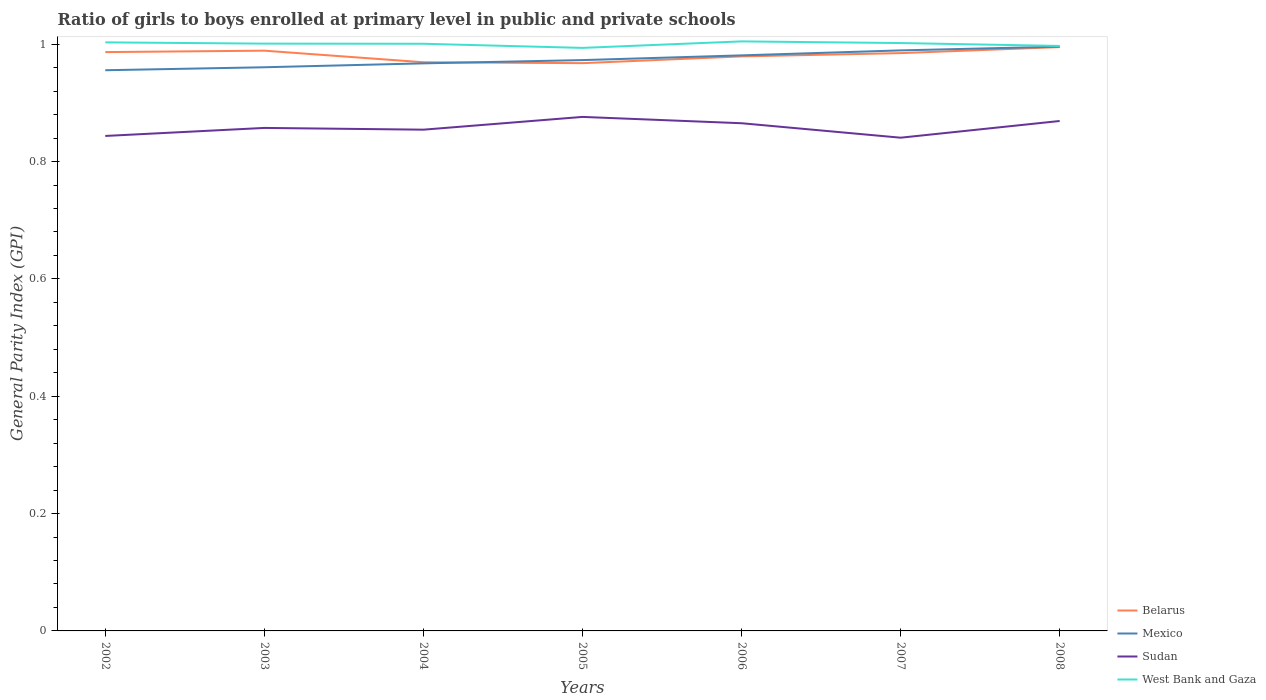Across all years, what is the maximum general parity index in West Bank and Gaza?
Offer a very short reply. 0.99. What is the total general parity index in Sudan in the graph?
Your answer should be very brief. -0.02. What is the difference between the highest and the second highest general parity index in West Bank and Gaza?
Provide a succinct answer. 0.01. What is the difference between the highest and the lowest general parity index in Mexico?
Ensure brevity in your answer.  3. How many lines are there?
Your answer should be very brief. 4. How many years are there in the graph?
Give a very brief answer. 7. Does the graph contain any zero values?
Ensure brevity in your answer.  No. Where does the legend appear in the graph?
Give a very brief answer. Bottom right. What is the title of the graph?
Offer a terse response. Ratio of girls to boys enrolled at primary level in public and private schools. Does "Comoros" appear as one of the legend labels in the graph?
Offer a very short reply. No. What is the label or title of the Y-axis?
Make the answer very short. General Parity Index (GPI). What is the General Parity Index (GPI) in Belarus in 2002?
Ensure brevity in your answer.  0.99. What is the General Parity Index (GPI) in Mexico in 2002?
Give a very brief answer. 0.96. What is the General Parity Index (GPI) of Sudan in 2002?
Keep it short and to the point. 0.84. What is the General Parity Index (GPI) in West Bank and Gaza in 2002?
Your answer should be compact. 1. What is the General Parity Index (GPI) in Belarus in 2003?
Your answer should be compact. 0.99. What is the General Parity Index (GPI) of Mexico in 2003?
Offer a terse response. 0.96. What is the General Parity Index (GPI) of Sudan in 2003?
Offer a terse response. 0.86. What is the General Parity Index (GPI) of West Bank and Gaza in 2003?
Offer a very short reply. 1. What is the General Parity Index (GPI) of Belarus in 2004?
Provide a short and direct response. 0.97. What is the General Parity Index (GPI) of Mexico in 2004?
Your answer should be very brief. 0.97. What is the General Parity Index (GPI) in Sudan in 2004?
Give a very brief answer. 0.85. What is the General Parity Index (GPI) of West Bank and Gaza in 2004?
Offer a terse response. 1. What is the General Parity Index (GPI) in Belarus in 2005?
Provide a short and direct response. 0.97. What is the General Parity Index (GPI) of Mexico in 2005?
Offer a very short reply. 0.97. What is the General Parity Index (GPI) of Sudan in 2005?
Keep it short and to the point. 0.88. What is the General Parity Index (GPI) of West Bank and Gaza in 2005?
Keep it short and to the point. 0.99. What is the General Parity Index (GPI) in Belarus in 2006?
Keep it short and to the point. 0.98. What is the General Parity Index (GPI) of Mexico in 2006?
Your response must be concise. 0.98. What is the General Parity Index (GPI) of Sudan in 2006?
Offer a terse response. 0.87. What is the General Parity Index (GPI) of West Bank and Gaza in 2006?
Ensure brevity in your answer.  1. What is the General Parity Index (GPI) in Belarus in 2007?
Give a very brief answer. 0.98. What is the General Parity Index (GPI) in Mexico in 2007?
Your response must be concise. 0.99. What is the General Parity Index (GPI) in Sudan in 2007?
Provide a short and direct response. 0.84. What is the General Parity Index (GPI) of West Bank and Gaza in 2007?
Your answer should be very brief. 1. What is the General Parity Index (GPI) in Belarus in 2008?
Provide a short and direct response. 1. What is the General Parity Index (GPI) of Mexico in 2008?
Provide a succinct answer. 1. What is the General Parity Index (GPI) in Sudan in 2008?
Ensure brevity in your answer.  0.87. What is the General Parity Index (GPI) in West Bank and Gaza in 2008?
Keep it short and to the point. 1. Across all years, what is the maximum General Parity Index (GPI) in Belarus?
Ensure brevity in your answer.  1. Across all years, what is the maximum General Parity Index (GPI) in Mexico?
Your response must be concise. 1. Across all years, what is the maximum General Parity Index (GPI) of Sudan?
Your answer should be very brief. 0.88. Across all years, what is the maximum General Parity Index (GPI) of West Bank and Gaza?
Offer a very short reply. 1. Across all years, what is the minimum General Parity Index (GPI) of Belarus?
Make the answer very short. 0.97. Across all years, what is the minimum General Parity Index (GPI) in Mexico?
Your answer should be very brief. 0.96. Across all years, what is the minimum General Parity Index (GPI) in Sudan?
Give a very brief answer. 0.84. Across all years, what is the minimum General Parity Index (GPI) in West Bank and Gaza?
Provide a short and direct response. 0.99. What is the total General Parity Index (GPI) of Belarus in the graph?
Provide a succinct answer. 6.87. What is the total General Parity Index (GPI) in Mexico in the graph?
Offer a terse response. 6.82. What is the total General Parity Index (GPI) of Sudan in the graph?
Ensure brevity in your answer.  6.01. What is the total General Parity Index (GPI) of West Bank and Gaza in the graph?
Offer a very short reply. 7. What is the difference between the General Parity Index (GPI) in Belarus in 2002 and that in 2003?
Make the answer very short. -0. What is the difference between the General Parity Index (GPI) of Mexico in 2002 and that in 2003?
Provide a succinct answer. -0.01. What is the difference between the General Parity Index (GPI) of Sudan in 2002 and that in 2003?
Provide a succinct answer. -0.01. What is the difference between the General Parity Index (GPI) of West Bank and Gaza in 2002 and that in 2003?
Offer a terse response. 0. What is the difference between the General Parity Index (GPI) in Belarus in 2002 and that in 2004?
Provide a succinct answer. 0.02. What is the difference between the General Parity Index (GPI) in Mexico in 2002 and that in 2004?
Give a very brief answer. -0.01. What is the difference between the General Parity Index (GPI) of Sudan in 2002 and that in 2004?
Provide a short and direct response. -0.01. What is the difference between the General Parity Index (GPI) in West Bank and Gaza in 2002 and that in 2004?
Your answer should be very brief. 0. What is the difference between the General Parity Index (GPI) in Belarus in 2002 and that in 2005?
Make the answer very short. 0.02. What is the difference between the General Parity Index (GPI) in Mexico in 2002 and that in 2005?
Give a very brief answer. -0.02. What is the difference between the General Parity Index (GPI) of Sudan in 2002 and that in 2005?
Ensure brevity in your answer.  -0.03. What is the difference between the General Parity Index (GPI) of West Bank and Gaza in 2002 and that in 2005?
Keep it short and to the point. 0.01. What is the difference between the General Parity Index (GPI) in Belarus in 2002 and that in 2006?
Your response must be concise. 0.01. What is the difference between the General Parity Index (GPI) of Mexico in 2002 and that in 2006?
Offer a terse response. -0.03. What is the difference between the General Parity Index (GPI) in Sudan in 2002 and that in 2006?
Make the answer very short. -0.02. What is the difference between the General Parity Index (GPI) of West Bank and Gaza in 2002 and that in 2006?
Ensure brevity in your answer.  -0. What is the difference between the General Parity Index (GPI) of Belarus in 2002 and that in 2007?
Your answer should be very brief. 0. What is the difference between the General Parity Index (GPI) in Mexico in 2002 and that in 2007?
Your answer should be compact. -0.03. What is the difference between the General Parity Index (GPI) in Sudan in 2002 and that in 2007?
Keep it short and to the point. 0. What is the difference between the General Parity Index (GPI) of West Bank and Gaza in 2002 and that in 2007?
Offer a terse response. 0. What is the difference between the General Parity Index (GPI) in Belarus in 2002 and that in 2008?
Keep it short and to the point. -0.01. What is the difference between the General Parity Index (GPI) of Mexico in 2002 and that in 2008?
Provide a short and direct response. -0.04. What is the difference between the General Parity Index (GPI) of Sudan in 2002 and that in 2008?
Your response must be concise. -0.03. What is the difference between the General Parity Index (GPI) in West Bank and Gaza in 2002 and that in 2008?
Offer a very short reply. 0.01. What is the difference between the General Parity Index (GPI) of Belarus in 2003 and that in 2004?
Give a very brief answer. 0.02. What is the difference between the General Parity Index (GPI) of Mexico in 2003 and that in 2004?
Offer a very short reply. -0.01. What is the difference between the General Parity Index (GPI) in Sudan in 2003 and that in 2004?
Offer a terse response. 0. What is the difference between the General Parity Index (GPI) in Belarus in 2003 and that in 2005?
Make the answer very short. 0.02. What is the difference between the General Parity Index (GPI) in Mexico in 2003 and that in 2005?
Ensure brevity in your answer.  -0.01. What is the difference between the General Parity Index (GPI) of Sudan in 2003 and that in 2005?
Offer a very short reply. -0.02. What is the difference between the General Parity Index (GPI) of West Bank and Gaza in 2003 and that in 2005?
Your response must be concise. 0.01. What is the difference between the General Parity Index (GPI) of Belarus in 2003 and that in 2006?
Provide a short and direct response. 0.01. What is the difference between the General Parity Index (GPI) in Mexico in 2003 and that in 2006?
Offer a very short reply. -0.02. What is the difference between the General Parity Index (GPI) in Sudan in 2003 and that in 2006?
Offer a terse response. -0.01. What is the difference between the General Parity Index (GPI) of West Bank and Gaza in 2003 and that in 2006?
Offer a terse response. -0. What is the difference between the General Parity Index (GPI) in Belarus in 2003 and that in 2007?
Your answer should be very brief. 0. What is the difference between the General Parity Index (GPI) of Mexico in 2003 and that in 2007?
Offer a terse response. -0.03. What is the difference between the General Parity Index (GPI) of Sudan in 2003 and that in 2007?
Ensure brevity in your answer.  0.02. What is the difference between the General Parity Index (GPI) of West Bank and Gaza in 2003 and that in 2007?
Your response must be concise. -0. What is the difference between the General Parity Index (GPI) of Belarus in 2003 and that in 2008?
Your answer should be compact. -0.01. What is the difference between the General Parity Index (GPI) of Mexico in 2003 and that in 2008?
Offer a very short reply. -0.04. What is the difference between the General Parity Index (GPI) in Sudan in 2003 and that in 2008?
Ensure brevity in your answer.  -0.01. What is the difference between the General Parity Index (GPI) of West Bank and Gaza in 2003 and that in 2008?
Offer a very short reply. 0. What is the difference between the General Parity Index (GPI) of Belarus in 2004 and that in 2005?
Provide a succinct answer. 0. What is the difference between the General Parity Index (GPI) in Mexico in 2004 and that in 2005?
Make the answer very short. -0.01. What is the difference between the General Parity Index (GPI) in Sudan in 2004 and that in 2005?
Keep it short and to the point. -0.02. What is the difference between the General Parity Index (GPI) in West Bank and Gaza in 2004 and that in 2005?
Ensure brevity in your answer.  0.01. What is the difference between the General Parity Index (GPI) in Belarus in 2004 and that in 2006?
Provide a succinct answer. -0.01. What is the difference between the General Parity Index (GPI) of Mexico in 2004 and that in 2006?
Your answer should be very brief. -0.01. What is the difference between the General Parity Index (GPI) in Sudan in 2004 and that in 2006?
Give a very brief answer. -0.01. What is the difference between the General Parity Index (GPI) of West Bank and Gaza in 2004 and that in 2006?
Your answer should be compact. -0. What is the difference between the General Parity Index (GPI) in Belarus in 2004 and that in 2007?
Make the answer very short. -0.02. What is the difference between the General Parity Index (GPI) in Mexico in 2004 and that in 2007?
Your answer should be very brief. -0.02. What is the difference between the General Parity Index (GPI) of Sudan in 2004 and that in 2007?
Your response must be concise. 0.01. What is the difference between the General Parity Index (GPI) in West Bank and Gaza in 2004 and that in 2007?
Your response must be concise. -0. What is the difference between the General Parity Index (GPI) of Belarus in 2004 and that in 2008?
Ensure brevity in your answer.  -0.03. What is the difference between the General Parity Index (GPI) in Mexico in 2004 and that in 2008?
Ensure brevity in your answer.  -0.03. What is the difference between the General Parity Index (GPI) of Sudan in 2004 and that in 2008?
Your response must be concise. -0.01. What is the difference between the General Parity Index (GPI) of West Bank and Gaza in 2004 and that in 2008?
Provide a short and direct response. 0. What is the difference between the General Parity Index (GPI) of Belarus in 2005 and that in 2006?
Your answer should be compact. -0.01. What is the difference between the General Parity Index (GPI) in Mexico in 2005 and that in 2006?
Ensure brevity in your answer.  -0.01. What is the difference between the General Parity Index (GPI) in Sudan in 2005 and that in 2006?
Your answer should be very brief. 0.01. What is the difference between the General Parity Index (GPI) in West Bank and Gaza in 2005 and that in 2006?
Ensure brevity in your answer.  -0.01. What is the difference between the General Parity Index (GPI) in Belarus in 2005 and that in 2007?
Offer a very short reply. -0.02. What is the difference between the General Parity Index (GPI) in Mexico in 2005 and that in 2007?
Provide a short and direct response. -0.02. What is the difference between the General Parity Index (GPI) of Sudan in 2005 and that in 2007?
Give a very brief answer. 0.04. What is the difference between the General Parity Index (GPI) of West Bank and Gaza in 2005 and that in 2007?
Offer a very short reply. -0.01. What is the difference between the General Parity Index (GPI) in Belarus in 2005 and that in 2008?
Your answer should be compact. -0.03. What is the difference between the General Parity Index (GPI) in Mexico in 2005 and that in 2008?
Provide a short and direct response. -0.02. What is the difference between the General Parity Index (GPI) of Sudan in 2005 and that in 2008?
Offer a very short reply. 0.01. What is the difference between the General Parity Index (GPI) in West Bank and Gaza in 2005 and that in 2008?
Your answer should be compact. -0. What is the difference between the General Parity Index (GPI) of Belarus in 2006 and that in 2007?
Offer a very short reply. -0.01. What is the difference between the General Parity Index (GPI) in Mexico in 2006 and that in 2007?
Provide a succinct answer. -0.01. What is the difference between the General Parity Index (GPI) in Sudan in 2006 and that in 2007?
Your response must be concise. 0.02. What is the difference between the General Parity Index (GPI) of West Bank and Gaza in 2006 and that in 2007?
Offer a very short reply. 0. What is the difference between the General Parity Index (GPI) in Belarus in 2006 and that in 2008?
Provide a succinct answer. -0.02. What is the difference between the General Parity Index (GPI) of Mexico in 2006 and that in 2008?
Offer a terse response. -0.01. What is the difference between the General Parity Index (GPI) of Sudan in 2006 and that in 2008?
Offer a terse response. -0. What is the difference between the General Parity Index (GPI) of West Bank and Gaza in 2006 and that in 2008?
Give a very brief answer. 0.01. What is the difference between the General Parity Index (GPI) of Belarus in 2007 and that in 2008?
Your response must be concise. -0.01. What is the difference between the General Parity Index (GPI) of Mexico in 2007 and that in 2008?
Your response must be concise. -0.01. What is the difference between the General Parity Index (GPI) of Sudan in 2007 and that in 2008?
Offer a terse response. -0.03. What is the difference between the General Parity Index (GPI) in West Bank and Gaza in 2007 and that in 2008?
Your answer should be compact. 0. What is the difference between the General Parity Index (GPI) in Belarus in 2002 and the General Parity Index (GPI) in Mexico in 2003?
Provide a succinct answer. 0.03. What is the difference between the General Parity Index (GPI) in Belarus in 2002 and the General Parity Index (GPI) in Sudan in 2003?
Ensure brevity in your answer.  0.13. What is the difference between the General Parity Index (GPI) of Belarus in 2002 and the General Parity Index (GPI) of West Bank and Gaza in 2003?
Offer a terse response. -0.01. What is the difference between the General Parity Index (GPI) in Mexico in 2002 and the General Parity Index (GPI) in Sudan in 2003?
Ensure brevity in your answer.  0.1. What is the difference between the General Parity Index (GPI) of Mexico in 2002 and the General Parity Index (GPI) of West Bank and Gaza in 2003?
Your answer should be compact. -0.05. What is the difference between the General Parity Index (GPI) in Sudan in 2002 and the General Parity Index (GPI) in West Bank and Gaza in 2003?
Your answer should be very brief. -0.16. What is the difference between the General Parity Index (GPI) in Belarus in 2002 and the General Parity Index (GPI) in Mexico in 2004?
Ensure brevity in your answer.  0.02. What is the difference between the General Parity Index (GPI) in Belarus in 2002 and the General Parity Index (GPI) in Sudan in 2004?
Offer a very short reply. 0.13. What is the difference between the General Parity Index (GPI) of Belarus in 2002 and the General Parity Index (GPI) of West Bank and Gaza in 2004?
Offer a terse response. -0.01. What is the difference between the General Parity Index (GPI) in Mexico in 2002 and the General Parity Index (GPI) in Sudan in 2004?
Provide a succinct answer. 0.1. What is the difference between the General Parity Index (GPI) of Mexico in 2002 and the General Parity Index (GPI) of West Bank and Gaza in 2004?
Keep it short and to the point. -0.05. What is the difference between the General Parity Index (GPI) in Sudan in 2002 and the General Parity Index (GPI) in West Bank and Gaza in 2004?
Keep it short and to the point. -0.16. What is the difference between the General Parity Index (GPI) in Belarus in 2002 and the General Parity Index (GPI) in Mexico in 2005?
Your answer should be very brief. 0.01. What is the difference between the General Parity Index (GPI) of Belarus in 2002 and the General Parity Index (GPI) of Sudan in 2005?
Ensure brevity in your answer.  0.11. What is the difference between the General Parity Index (GPI) in Belarus in 2002 and the General Parity Index (GPI) in West Bank and Gaza in 2005?
Your response must be concise. -0.01. What is the difference between the General Parity Index (GPI) of Mexico in 2002 and the General Parity Index (GPI) of Sudan in 2005?
Make the answer very short. 0.08. What is the difference between the General Parity Index (GPI) of Mexico in 2002 and the General Parity Index (GPI) of West Bank and Gaza in 2005?
Give a very brief answer. -0.04. What is the difference between the General Parity Index (GPI) of Sudan in 2002 and the General Parity Index (GPI) of West Bank and Gaza in 2005?
Provide a succinct answer. -0.15. What is the difference between the General Parity Index (GPI) of Belarus in 2002 and the General Parity Index (GPI) of Mexico in 2006?
Give a very brief answer. 0.01. What is the difference between the General Parity Index (GPI) of Belarus in 2002 and the General Parity Index (GPI) of Sudan in 2006?
Give a very brief answer. 0.12. What is the difference between the General Parity Index (GPI) of Belarus in 2002 and the General Parity Index (GPI) of West Bank and Gaza in 2006?
Your response must be concise. -0.02. What is the difference between the General Parity Index (GPI) in Mexico in 2002 and the General Parity Index (GPI) in Sudan in 2006?
Provide a succinct answer. 0.09. What is the difference between the General Parity Index (GPI) in Mexico in 2002 and the General Parity Index (GPI) in West Bank and Gaza in 2006?
Offer a terse response. -0.05. What is the difference between the General Parity Index (GPI) of Sudan in 2002 and the General Parity Index (GPI) of West Bank and Gaza in 2006?
Make the answer very short. -0.16. What is the difference between the General Parity Index (GPI) of Belarus in 2002 and the General Parity Index (GPI) of Mexico in 2007?
Your answer should be compact. -0. What is the difference between the General Parity Index (GPI) of Belarus in 2002 and the General Parity Index (GPI) of Sudan in 2007?
Provide a succinct answer. 0.15. What is the difference between the General Parity Index (GPI) in Belarus in 2002 and the General Parity Index (GPI) in West Bank and Gaza in 2007?
Make the answer very short. -0.02. What is the difference between the General Parity Index (GPI) of Mexico in 2002 and the General Parity Index (GPI) of Sudan in 2007?
Make the answer very short. 0.12. What is the difference between the General Parity Index (GPI) of Mexico in 2002 and the General Parity Index (GPI) of West Bank and Gaza in 2007?
Your response must be concise. -0.05. What is the difference between the General Parity Index (GPI) of Sudan in 2002 and the General Parity Index (GPI) of West Bank and Gaza in 2007?
Provide a short and direct response. -0.16. What is the difference between the General Parity Index (GPI) of Belarus in 2002 and the General Parity Index (GPI) of Mexico in 2008?
Ensure brevity in your answer.  -0.01. What is the difference between the General Parity Index (GPI) of Belarus in 2002 and the General Parity Index (GPI) of Sudan in 2008?
Ensure brevity in your answer.  0.12. What is the difference between the General Parity Index (GPI) in Belarus in 2002 and the General Parity Index (GPI) in West Bank and Gaza in 2008?
Your response must be concise. -0.01. What is the difference between the General Parity Index (GPI) in Mexico in 2002 and the General Parity Index (GPI) in Sudan in 2008?
Provide a succinct answer. 0.09. What is the difference between the General Parity Index (GPI) of Mexico in 2002 and the General Parity Index (GPI) of West Bank and Gaza in 2008?
Offer a terse response. -0.04. What is the difference between the General Parity Index (GPI) in Sudan in 2002 and the General Parity Index (GPI) in West Bank and Gaza in 2008?
Keep it short and to the point. -0.15. What is the difference between the General Parity Index (GPI) in Belarus in 2003 and the General Parity Index (GPI) in Mexico in 2004?
Provide a succinct answer. 0.02. What is the difference between the General Parity Index (GPI) in Belarus in 2003 and the General Parity Index (GPI) in Sudan in 2004?
Offer a terse response. 0.13. What is the difference between the General Parity Index (GPI) of Belarus in 2003 and the General Parity Index (GPI) of West Bank and Gaza in 2004?
Give a very brief answer. -0.01. What is the difference between the General Parity Index (GPI) of Mexico in 2003 and the General Parity Index (GPI) of Sudan in 2004?
Make the answer very short. 0.11. What is the difference between the General Parity Index (GPI) of Mexico in 2003 and the General Parity Index (GPI) of West Bank and Gaza in 2004?
Make the answer very short. -0.04. What is the difference between the General Parity Index (GPI) in Sudan in 2003 and the General Parity Index (GPI) in West Bank and Gaza in 2004?
Your response must be concise. -0.14. What is the difference between the General Parity Index (GPI) in Belarus in 2003 and the General Parity Index (GPI) in Mexico in 2005?
Give a very brief answer. 0.02. What is the difference between the General Parity Index (GPI) in Belarus in 2003 and the General Parity Index (GPI) in Sudan in 2005?
Your answer should be compact. 0.11. What is the difference between the General Parity Index (GPI) of Belarus in 2003 and the General Parity Index (GPI) of West Bank and Gaza in 2005?
Your answer should be very brief. -0. What is the difference between the General Parity Index (GPI) of Mexico in 2003 and the General Parity Index (GPI) of Sudan in 2005?
Your response must be concise. 0.08. What is the difference between the General Parity Index (GPI) in Mexico in 2003 and the General Parity Index (GPI) in West Bank and Gaza in 2005?
Provide a short and direct response. -0.03. What is the difference between the General Parity Index (GPI) of Sudan in 2003 and the General Parity Index (GPI) of West Bank and Gaza in 2005?
Offer a very short reply. -0.14. What is the difference between the General Parity Index (GPI) of Belarus in 2003 and the General Parity Index (GPI) of Mexico in 2006?
Your answer should be very brief. 0.01. What is the difference between the General Parity Index (GPI) in Belarus in 2003 and the General Parity Index (GPI) in Sudan in 2006?
Give a very brief answer. 0.12. What is the difference between the General Parity Index (GPI) in Belarus in 2003 and the General Parity Index (GPI) in West Bank and Gaza in 2006?
Your answer should be very brief. -0.02. What is the difference between the General Parity Index (GPI) in Mexico in 2003 and the General Parity Index (GPI) in Sudan in 2006?
Your answer should be compact. 0.1. What is the difference between the General Parity Index (GPI) of Mexico in 2003 and the General Parity Index (GPI) of West Bank and Gaza in 2006?
Your response must be concise. -0.04. What is the difference between the General Parity Index (GPI) of Sudan in 2003 and the General Parity Index (GPI) of West Bank and Gaza in 2006?
Offer a very short reply. -0.15. What is the difference between the General Parity Index (GPI) of Belarus in 2003 and the General Parity Index (GPI) of Mexico in 2007?
Offer a terse response. -0. What is the difference between the General Parity Index (GPI) of Belarus in 2003 and the General Parity Index (GPI) of Sudan in 2007?
Your response must be concise. 0.15. What is the difference between the General Parity Index (GPI) in Belarus in 2003 and the General Parity Index (GPI) in West Bank and Gaza in 2007?
Give a very brief answer. -0.01. What is the difference between the General Parity Index (GPI) of Mexico in 2003 and the General Parity Index (GPI) of Sudan in 2007?
Make the answer very short. 0.12. What is the difference between the General Parity Index (GPI) of Mexico in 2003 and the General Parity Index (GPI) of West Bank and Gaza in 2007?
Give a very brief answer. -0.04. What is the difference between the General Parity Index (GPI) of Sudan in 2003 and the General Parity Index (GPI) of West Bank and Gaza in 2007?
Your answer should be compact. -0.14. What is the difference between the General Parity Index (GPI) in Belarus in 2003 and the General Parity Index (GPI) in Mexico in 2008?
Keep it short and to the point. -0.01. What is the difference between the General Parity Index (GPI) in Belarus in 2003 and the General Parity Index (GPI) in Sudan in 2008?
Provide a succinct answer. 0.12. What is the difference between the General Parity Index (GPI) in Belarus in 2003 and the General Parity Index (GPI) in West Bank and Gaza in 2008?
Provide a short and direct response. -0.01. What is the difference between the General Parity Index (GPI) in Mexico in 2003 and the General Parity Index (GPI) in Sudan in 2008?
Give a very brief answer. 0.09. What is the difference between the General Parity Index (GPI) of Mexico in 2003 and the General Parity Index (GPI) of West Bank and Gaza in 2008?
Ensure brevity in your answer.  -0.04. What is the difference between the General Parity Index (GPI) of Sudan in 2003 and the General Parity Index (GPI) of West Bank and Gaza in 2008?
Your response must be concise. -0.14. What is the difference between the General Parity Index (GPI) of Belarus in 2004 and the General Parity Index (GPI) of Mexico in 2005?
Ensure brevity in your answer.  -0. What is the difference between the General Parity Index (GPI) of Belarus in 2004 and the General Parity Index (GPI) of Sudan in 2005?
Offer a very short reply. 0.09. What is the difference between the General Parity Index (GPI) of Belarus in 2004 and the General Parity Index (GPI) of West Bank and Gaza in 2005?
Provide a succinct answer. -0.02. What is the difference between the General Parity Index (GPI) of Mexico in 2004 and the General Parity Index (GPI) of Sudan in 2005?
Keep it short and to the point. 0.09. What is the difference between the General Parity Index (GPI) of Mexico in 2004 and the General Parity Index (GPI) of West Bank and Gaza in 2005?
Ensure brevity in your answer.  -0.03. What is the difference between the General Parity Index (GPI) of Sudan in 2004 and the General Parity Index (GPI) of West Bank and Gaza in 2005?
Keep it short and to the point. -0.14. What is the difference between the General Parity Index (GPI) in Belarus in 2004 and the General Parity Index (GPI) in Mexico in 2006?
Your answer should be compact. -0.01. What is the difference between the General Parity Index (GPI) in Belarus in 2004 and the General Parity Index (GPI) in Sudan in 2006?
Give a very brief answer. 0.1. What is the difference between the General Parity Index (GPI) of Belarus in 2004 and the General Parity Index (GPI) of West Bank and Gaza in 2006?
Provide a succinct answer. -0.04. What is the difference between the General Parity Index (GPI) of Mexico in 2004 and the General Parity Index (GPI) of Sudan in 2006?
Your answer should be very brief. 0.1. What is the difference between the General Parity Index (GPI) in Mexico in 2004 and the General Parity Index (GPI) in West Bank and Gaza in 2006?
Provide a short and direct response. -0.04. What is the difference between the General Parity Index (GPI) of Sudan in 2004 and the General Parity Index (GPI) of West Bank and Gaza in 2006?
Your answer should be very brief. -0.15. What is the difference between the General Parity Index (GPI) in Belarus in 2004 and the General Parity Index (GPI) in Mexico in 2007?
Make the answer very short. -0.02. What is the difference between the General Parity Index (GPI) in Belarus in 2004 and the General Parity Index (GPI) in Sudan in 2007?
Give a very brief answer. 0.13. What is the difference between the General Parity Index (GPI) in Belarus in 2004 and the General Parity Index (GPI) in West Bank and Gaza in 2007?
Give a very brief answer. -0.03. What is the difference between the General Parity Index (GPI) of Mexico in 2004 and the General Parity Index (GPI) of Sudan in 2007?
Your answer should be compact. 0.13. What is the difference between the General Parity Index (GPI) in Mexico in 2004 and the General Parity Index (GPI) in West Bank and Gaza in 2007?
Your answer should be compact. -0.03. What is the difference between the General Parity Index (GPI) of Sudan in 2004 and the General Parity Index (GPI) of West Bank and Gaza in 2007?
Your answer should be very brief. -0.15. What is the difference between the General Parity Index (GPI) in Belarus in 2004 and the General Parity Index (GPI) in Mexico in 2008?
Ensure brevity in your answer.  -0.03. What is the difference between the General Parity Index (GPI) of Belarus in 2004 and the General Parity Index (GPI) of Sudan in 2008?
Offer a terse response. 0.1. What is the difference between the General Parity Index (GPI) of Belarus in 2004 and the General Parity Index (GPI) of West Bank and Gaza in 2008?
Your answer should be compact. -0.03. What is the difference between the General Parity Index (GPI) in Mexico in 2004 and the General Parity Index (GPI) in Sudan in 2008?
Offer a very short reply. 0.1. What is the difference between the General Parity Index (GPI) of Mexico in 2004 and the General Parity Index (GPI) of West Bank and Gaza in 2008?
Provide a succinct answer. -0.03. What is the difference between the General Parity Index (GPI) of Sudan in 2004 and the General Parity Index (GPI) of West Bank and Gaza in 2008?
Give a very brief answer. -0.14. What is the difference between the General Parity Index (GPI) in Belarus in 2005 and the General Parity Index (GPI) in Mexico in 2006?
Provide a short and direct response. -0.01. What is the difference between the General Parity Index (GPI) of Belarus in 2005 and the General Parity Index (GPI) of Sudan in 2006?
Offer a very short reply. 0.1. What is the difference between the General Parity Index (GPI) of Belarus in 2005 and the General Parity Index (GPI) of West Bank and Gaza in 2006?
Provide a succinct answer. -0.04. What is the difference between the General Parity Index (GPI) in Mexico in 2005 and the General Parity Index (GPI) in Sudan in 2006?
Ensure brevity in your answer.  0.11. What is the difference between the General Parity Index (GPI) of Mexico in 2005 and the General Parity Index (GPI) of West Bank and Gaza in 2006?
Your answer should be very brief. -0.03. What is the difference between the General Parity Index (GPI) of Sudan in 2005 and the General Parity Index (GPI) of West Bank and Gaza in 2006?
Your answer should be compact. -0.13. What is the difference between the General Parity Index (GPI) in Belarus in 2005 and the General Parity Index (GPI) in Mexico in 2007?
Your response must be concise. -0.02. What is the difference between the General Parity Index (GPI) of Belarus in 2005 and the General Parity Index (GPI) of Sudan in 2007?
Offer a terse response. 0.13. What is the difference between the General Parity Index (GPI) of Belarus in 2005 and the General Parity Index (GPI) of West Bank and Gaza in 2007?
Offer a terse response. -0.03. What is the difference between the General Parity Index (GPI) of Mexico in 2005 and the General Parity Index (GPI) of Sudan in 2007?
Provide a short and direct response. 0.13. What is the difference between the General Parity Index (GPI) in Mexico in 2005 and the General Parity Index (GPI) in West Bank and Gaza in 2007?
Make the answer very short. -0.03. What is the difference between the General Parity Index (GPI) in Sudan in 2005 and the General Parity Index (GPI) in West Bank and Gaza in 2007?
Keep it short and to the point. -0.13. What is the difference between the General Parity Index (GPI) of Belarus in 2005 and the General Parity Index (GPI) of Mexico in 2008?
Your answer should be very brief. -0.03. What is the difference between the General Parity Index (GPI) of Belarus in 2005 and the General Parity Index (GPI) of Sudan in 2008?
Keep it short and to the point. 0.1. What is the difference between the General Parity Index (GPI) of Belarus in 2005 and the General Parity Index (GPI) of West Bank and Gaza in 2008?
Provide a succinct answer. -0.03. What is the difference between the General Parity Index (GPI) in Mexico in 2005 and the General Parity Index (GPI) in Sudan in 2008?
Provide a short and direct response. 0.1. What is the difference between the General Parity Index (GPI) of Mexico in 2005 and the General Parity Index (GPI) of West Bank and Gaza in 2008?
Offer a terse response. -0.02. What is the difference between the General Parity Index (GPI) in Sudan in 2005 and the General Parity Index (GPI) in West Bank and Gaza in 2008?
Make the answer very short. -0.12. What is the difference between the General Parity Index (GPI) in Belarus in 2006 and the General Parity Index (GPI) in Mexico in 2007?
Your answer should be very brief. -0.01. What is the difference between the General Parity Index (GPI) of Belarus in 2006 and the General Parity Index (GPI) of Sudan in 2007?
Your answer should be compact. 0.14. What is the difference between the General Parity Index (GPI) in Belarus in 2006 and the General Parity Index (GPI) in West Bank and Gaza in 2007?
Your answer should be very brief. -0.02. What is the difference between the General Parity Index (GPI) of Mexico in 2006 and the General Parity Index (GPI) of Sudan in 2007?
Provide a short and direct response. 0.14. What is the difference between the General Parity Index (GPI) in Mexico in 2006 and the General Parity Index (GPI) in West Bank and Gaza in 2007?
Your answer should be compact. -0.02. What is the difference between the General Parity Index (GPI) of Sudan in 2006 and the General Parity Index (GPI) of West Bank and Gaza in 2007?
Offer a very short reply. -0.14. What is the difference between the General Parity Index (GPI) of Belarus in 2006 and the General Parity Index (GPI) of Mexico in 2008?
Your answer should be very brief. -0.02. What is the difference between the General Parity Index (GPI) of Belarus in 2006 and the General Parity Index (GPI) of Sudan in 2008?
Provide a succinct answer. 0.11. What is the difference between the General Parity Index (GPI) of Belarus in 2006 and the General Parity Index (GPI) of West Bank and Gaza in 2008?
Give a very brief answer. -0.02. What is the difference between the General Parity Index (GPI) of Mexico in 2006 and the General Parity Index (GPI) of Sudan in 2008?
Your response must be concise. 0.11. What is the difference between the General Parity Index (GPI) of Mexico in 2006 and the General Parity Index (GPI) of West Bank and Gaza in 2008?
Keep it short and to the point. -0.02. What is the difference between the General Parity Index (GPI) of Sudan in 2006 and the General Parity Index (GPI) of West Bank and Gaza in 2008?
Offer a terse response. -0.13. What is the difference between the General Parity Index (GPI) in Belarus in 2007 and the General Parity Index (GPI) in Mexico in 2008?
Provide a succinct answer. -0.01. What is the difference between the General Parity Index (GPI) in Belarus in 2007 and the General Parity Index (GPI) in Sudan in 2008?
Make the answer very short. 0.12. What is the difference between the General Parity Index (GPI) of Belarus in 2007 and the General Parity Index (GPI) of West Bank and Gaza in 2008?
Offer a terse response. -0.01. What is the difference between the General Parity Index (GPI) in Mexico in 2007 and the General Parity Index (GPI) in Sudan in 2008?
Offer a terse response. 0.12. What is the difference between the General Parity Index (GPI) of Mexico in 2007 and the General Parity Index (GPI) of West Bank and Gaza in 2008?
Your answer should be very brief. -0.01. What is the difference between the General Parity Index (GPI) of Sudan in 2007 and the General Parity Index (GPI) of West Bank and Gaza in 2008?
Offer a terse response. -0.16. What is the average General Parity Index (GPI) in Belarus per year?
Provide a succinct answer. 0.98. What is the average General Parity Index (GPI) in Mexico per year?
Your answer should be compact. 0.97. What is the average General Parity Index (GPI) of Sudan per year?
Keep it short and to the point. 0.86. What is the average General Parity Index (GPI) in West Bank and Gaza per year?
Your answer should be compact. 1. In the year 2002, what is the difference between the General Parity Index (GPI) in Belarus and General Parity Index (GPI) in Mexico?
Provide a short and direct response. 0.03. In the year 2002, what is the difference between the General Parity Index (GPI) in Belarus and General Parity Index (GPI) in Sudan?
Keep it short and to the point. 0.14. In the year 2002, what is the difference between the General Parity Index (GPI) in Belarus and General Parity Index (GPI) in West Bank and Gaza?
Give a very brief answer. -0.02. In the year 2002, what is the difference between the General Parity Index (GPI) in Mexico and General Parity Index (GPI) in Sudan?
Your answer should be very brief. 0.11. In the year 2002, what is the difference between the General Parity Index (GPI) in Mexico and General Parity Index (GPI) in West Bank and Gaza?
Offer a very short reply. -0.05. In the year 2002, what is the difference between the General Parity Index (GPI) in Sudan and General Parity Index (GPI) in West Bank and Gaza?
Keep it short and to the point. -0.16. In the year 2003, what is the difference between the General Parity Index (GPI) of Belarus and General Parity Index (GPI) of Mexico?
Offer a very short reply. 0.03. In the year 2003, what is the difference between the General Parity Index (GPI) of Belarus and General Parity Index (GPI) of Sudan?
Give a very brief answer. 0.13. In the year 2003, what is the difference between the General Parity Index (GPI) in Belarus and General Parity Index (GPI) in West Bank and Gaza?
Offer a terse response. -0.01. In the year 2003, what is the difference between the General Parity Index (GPI) of Mexico and General Parity Index (GPI) of Sudan?
Your response must be concise. 0.1. In the year 2003, what is the difference between the General Parity Index (GPI) of Mexico and General Parity Index (GPI) of West Bank and Gaza?
Offer a very short reply. -0.04. In the year 2003, what is the difference between the General Parity Index (GPI) in Sudan and General Parity Index (GPI) in West Bank and Gaza?
Give a very brief answer. -0.14. In the year 2004, what is the difference between the General Parity Index (GPI) in Belarus and General Parity Index (GPI) in Mexico?
Ensure brevity in your answer.  0. In the year 2004, what is the difference between the General Parity Index (GPI) of Belarus and General Parity Index (GPI) of Sudan?
Offer a very short reply. 0.11. In the year 2004, what is the difference between the General Parity Index (GPI) of Belarus and General Parity Index (GPI) of West Bank and Gaza?
Make the answer very short. -0.03. In the year 2004, what is the difference between the General Parity Index (GPI) in Mexico and General Parity Index (GPI) in Sudan?
Your response must be concise. 0.11. In the year 2004, what is the difference between the General Parity Index (GPI) of Mexico and General Parity Index (GPI) of West Bank and Gaza?
Ensure brevity in your answer.  -0.03. In the year 2004, what is the difference between the General Parity Index (GPI) of Sudan and General Parity Index (GPI) of West Bank and Gaza?
Keep it short and to the point. -0.15. In the year 2005, what is the difference between the General Parity Index (GPI) of Belarus and General Parity Index (GPI) of Mexico?
Provide a succinct answer. -0.01. In the year 2005, what is the difference between the General Parity Index (GPI) of Belarus and General Parity Index (GPI) of Sudan?
Keep it short and to the point. 0.09. In the year 2005, what is the difference between the General Parity Index (GPI) in Belarus and General Parity Index (GPI) in West Bank and Gaza?
Offer a terse response. -0.03. In the year 2005, what is the difference between the General Parity Index (GPI) of Mexico and General Parity Index (GPI) of Sudan?
Ensure brevity in your answer.  0.1. In the year 2005, what is the difference between the General Parity Index (GPI) in Mexico and General Parity Index (GPI) in West Bank and Gaza?
Your response must be concise. -0.02. In the year 2005, what is the difference between the General Parity Index (GPI) in Sudan and General Parity Index (GPI) in West Bank and Gaza?
Provide a succinct answer. -0.12. In the year 2006, what is the difference between the General Parity Index (GPI) in Belarus and General Parity Index (GPI) in Mexico?
Provide a short and direct response. -0. In the year 2006, what is the difference between the General Parity Index (GPI) of Belarus and General Parity Index (GPI) of Sudan?
Offer a very short reply. 0.11. In the year 2006, what is the difference between the General Parity Index (GPI) in Belarus and General Parity Index (GPI) in West Bank and Gaza?
Offer a very short reply. -0.03. In the year 2006, what is the difference between the General Parity Index (GPI) of Mexico and General Parity Index (GPI) of Sudan?
Keep it short and to the point. 0.12. In the year 2006, what is the difference between the General Parity Index (GPI) of Mexico and General Parity Index (GPI) of West Bank and Gaza?
Provide a succinct answer. -0.02. In the year 2006, what is the difference between the General Parity Index (GPI) in Sudan and General Parity Index (GPI) in West Bank and Gaza?
Your answer should be compact. -0.14. In the year 2007, what is the difference between the General Parity Index (GPI) in Belarus and General Parity Index (GPI) in Mexico?
Ensure brevity in your answer.  -0. In the year 2007, what is the difference between the General Parity Index (GPI) of Belarus and General Parity Index (GPI) of Sudan?
Give a very brief answer. 0.14. In the year 2007, what is the difference between the General Parity Index (GPI) of Belarus and General Parity Index (GPI) of West Bank and Gaza?
Your answer should be compact. -0.02. In the year 2007, what is the difference between the General Parity Index (GPI) of Mexico and General Parity Index (GPI) of Sudan?
Your answer should be compact. 0.15. In the year 2007, what is the difference between the General Parity Index (GPI) in Mexico and General Parity Index (GPI) in West Bank and Gaza?
Your answer should be compact. -0.01. In the year 2007, what is the difference between the General Parity Index (GPI) in Sudan and General Parity Index (GPI) in West Bank and Gaza?
Your answer should be compact. -0.16. In the year 2008, what is the difference between the General Parity Index (GPI) of Belarus and General Parity Index (GPI) of Mexico?
Offer a very short reply. -0. In the year 2008, what is the difference between the General Parity Index (GPI) in Belarus and General Parity Index (GPI) in Sudan?
Your response must be concise. 0.13. In the year 2008, what is the difference between the General Parity Index (GPI) of Belarus and General Parity Index (GPI) of West Bank and Gaza?
Keep it short and to the point. -0. In the year 2008, what is the difference between the General Parity Index (GPI) in Mexico and General Parity Index (GPI) in Sudan?
Your answer should be very brief. 0.13. In the year 2008, what is the difference between the General Parity Index (GPI) in Mexico and General Parity Index (GPI) in West Bank and Gaza?
Offer a terse response. -0. In the year 2008, what is the difference between the General Parity Index (GPI) of Sudan and General Parity Index (GPI) of West Bank and Gaza?
Offer a very short reply. -0.13. What is the ratio of the General Parity Index (GPI) of Belarus in 2002 to that in 2003?
Give a very brief answer. 1. What is the ratio of the General Parity Index (GPI) in Mexico in 2002 to that in 2003?
Give a very brief answer. 0.99. What is the ratio of the General Parity Index (GPI) in West Bank and Gaza in 2002 to that in 2003?
Your answer should be very brief. 1. What is the ratio of the General Parity Index (GPI) of Belarus in 2002 to that in 2004?
Ensure brevity in your answer.  1.02. What is the ratio of the General Parity Index (GPI) in Mexico in 2002 to that in 2004?
Your answer should be very brief. 0.99. What is the ratio of the General Parity Index (GPI) of Sudan in 2002 to that in 2004?
Make the answer very short. 0.99. What is the ratio of the General Parity Index (GPI) of West Bank and Gaza in 2002 to that in 2004?
Provide a short and direct response. 1. What is the ratio of the General Parity Index (GPI) in Belarus in 2002 to that in 2005?
Give a very brief answer. 1.02. What is the ratio of the General Parity Index (GPI) in Mexico in 2002 to that in 2005?
Your response must be concise. 0.98. What is the ratio of the General Parity Index (GPI) in Sudan in 2002 to that in 2005?
Provide a succinct answer. 0.96. What is the ratio of the General Parity Index (GPI) of West Bank and Gaza in 2002 to that in 2005?
Your response must be concise. 1.01. What is the ratio of the General Parity Index (GPI) in Belarus in 2002 to that in 2006?
Provide a succinct answer. 1.01. What is the ratio of the General Parity Index (GPI) in Mexico in 2002 to that in 2006?
Offer a very short reply. 0.97. What is the ratio of the General Parity Index (GPI) of Sudan in 2002 to that in 2006?
Your response must be concise. 0.97. What is the ratio of the General Parity Index (GPI) of Mexico in 2002 to that in 2007?
Keep it short and to the point. 0.97. What is the ratio of the General Parity Index (GPI) of Mexico in 2002 to that in 2008?
Provide a succinct answer. 0.96. What is the ratio of the General Parity Index (GPI) in Sudan in 2002 to that in 2008?
Ensure brevity in your answer.  0.97. What is the ratio of the General Parity Index (GPI) in Belarus in 2003 to that in 2004?
Your response must be concise. 1.02. What is the ratio of the General Parity Index (GPI) of Mexico in 2003 to that in 2004?
Offer a terse response. 0.99. What is the ratio of the General Parity Index (GPI) of Mexico in 2003 to that in 2005?
Your answer should be compact. 0.99. What is the ratio of the General Parity Index (GPI) of Sudan in 2003 to that in 2005?
Make the answer very short. 0.98. What is the ratio of the General Parity Index (GPI) of West Bank and Gaza in 2003 to that in 2005?
Keep it short and to the point. 1.01. What is the ratio of the General Parity Index (GPI) in Belarus in 2003 to that in 2006?
Provide a succinct answer. 1.01. What is the ratio of the General Parity Index (GPI) in Mexico in 2003 to that in 2006?
Give a very brief answer. 0.98. What is the ratio of the General Parity Index (GPI) in Sudan in 2003 to that in 2006?
Provide a short and direct response. 0.99. What is the ratio of the General Parity Index (GPI) of West Bank and Gaza in 2003 to that in 2006?
Offer a terse response. 1. What is the ratio of the General Parity Index (GPI) in Mexico in 2003 to that in 2007?
Provide a succinct answer. 0.97. What is the ratio of the General Parity Index (GPI) in Sudan in 2003 to that in 2007?
Offer a very short reply. 1.02. What is the ratio of the General Parity Index (GPI) in Belarus in 2003 to that in 2008?
Your answer should be very brief. 0.99. What is the ratio of the General Parity Index (GPI) of Mexico in 2003 to that in 2008?
Make the answer very short. 0.96. What is the ratio of the General Parity Index (GPI) of Sudan in 2003 to that in 2008?
Ensure brevity in your answer.  0.99. What is the ratio of the General Parity Index (GPI) in West Bank and Gaza in 2003 to that in 2008?
Give a very brief answer. 1. What is the ratio of the General Parity Index (GPI) in Mexico in 2004 to that in 2005?
Your answer should be very brief. 0.99. What is the ratio of the General Parity Index (GPI) in Sudan in 2004 to that in 2005?
Your response must be concise. 0.98. What is the ratio of the General Parity Index (GPI) of West Bank and Gaza in 2004 to that in 2005?
Your answer should be compact. 1.01. What is the ratio of the General Parity Index (GPI) of Belarus in 2004 to that in 2006?
Ensure brevity in your answer.  0.99. What is the ratio of the General Parity Index (GPI) of Mexico in 2004 to that in 2006?
Give a very brief answer. 0.99. What is the ratio of the General Parity Index (GPI) of Sudan in 2004 to that in 2006?
Offer a terse response. 0.99. What is the ratio of the General Parity Index (GPI) in West Bank and Gaza in 2004 to that in 2006?
Offer a very short reply. 1. What is the ratio of the General Parity Index (GPI) of Belarus in 2004 to that in 2007?
Keep it short and to the point. 0.98. What is the ratio of the General Parity Index (GPI) in Mexico in 2004 to that in 2007?
Your response must be concise. 0.98. What is the ratio of the General Parity Index (GPI) in Sudan in 2004 to that in 2007?
Keep it short and to the point. 1.02. What is the ratio of the General Parity Index (GPI) of Belarus in 2004 to that in 2008?
Provide a succinct answer. 0.97. What is the ratio of the General Parity Index (GPI) in Mexico in 2004 to that in 2008?
Your response must be concise. 0.97. What is the ratio of the General Parity Index (GPI) of Sudan in 2004 to that in 2008?
Your response must be concise. 0.98. What is the ratio of the General Parity Index (GPI) in Belarus in 2005 to that in 2006?
Offer a terse response. 0.99. What is the ratio of the General Parity Index (GPI) of Sudan in 2005 to that in 2006?
Your response must be concise. 1.01. What is the ratio of the General Parity Index (GPI) in Belarus in 2005 to that in 2007?
Your answer should be very brief. 0.98. What is the ratio of the General Parity Index (GPI) in Mexico in 2005 to that in 2007?
Offer a terse response. 0.98. What is the ratio of the General Parity Index (GPI) of Sudan in 2005 to that in 2007?
Your answer should be very brief. 1.04. What is the ratio of the General Parity Index (GPI) of West Bank and Gaza in 2005 to that in 2007?
Make the answer very short. 0.99. What is the ratio of the General Parity Index (GPI) of Belarus in 2005 to that in 2008?
Your response must be concise. 0.97. What is the ratio of the General Parity Index (GPI) of Sudan in 2006 to that in 2007?
Your answer should be very brief. 1.03. What is the ratio of the General Parity Index (GPI) of West Bank and Gaza in 2006 to that in 2007?
Your answer should be very brief. 1. What is the ratio of the General Parity Index (GPI) in Belarus in 2006 to that in 2008?
Provide a succinct answer. 0.98. What is the ratio of the General Parity Index (GPI) in Mexico in 2006 to that in 2008?
Provide a short and direct response. 0.99. What is the ratio of the General Parity Index (GPI) in West Bank and Gaza in 2006 to that in 2008?
Provide a succinct answer. 1.01. What is the ratio of the General Parity Index (GPI) of Belarus in 2007 to that in 2008?
Ensure brevity in your answer.  0.99. What is the ratio of the General Parity Index (GPI) in Sudan in 2007 to that in 2008?
Make the answer very short. 0.97. What is the ratio of the General Parity Index (GPI) of West Bank and Gaza in 2007 to that in 2008?
Your response must be concise. 1. What is the difference between the highest and the second highest General Parity Index (GPI) of Belarus?
Make the answer very short. 0.01. What is the difference between the highest and the second highest General Parity Index (GPI) of Mexico?
Your answer should be very brief. 0.01. What is the difference between the highest and the second highest General Parity Index (GPI) in Sudan?
Provide a short and direct response. 0.01. What is the difference between the highest and the second highest General Parity Index (GPI) in West Bank and Gaza?
Ensure brevity in your answer.  0. What is the difference between the highest and the lowest General Parity Index (GPI) in Belarus?
Provide a short and direct response. 0.03. What is the difference between the highest and the lowest General Parity Index (GPI) in Mexico?
Make the answer very short. 0.04. What is the difference between the highest and the lowest General Parity Index (GPI) of Sudan?
Offer a very short reply. 0.04. What is the difference between the highest and the lowest General Parity Index (GPI) in West Bank and Gaza?
Make the answer very short. 0.01. 